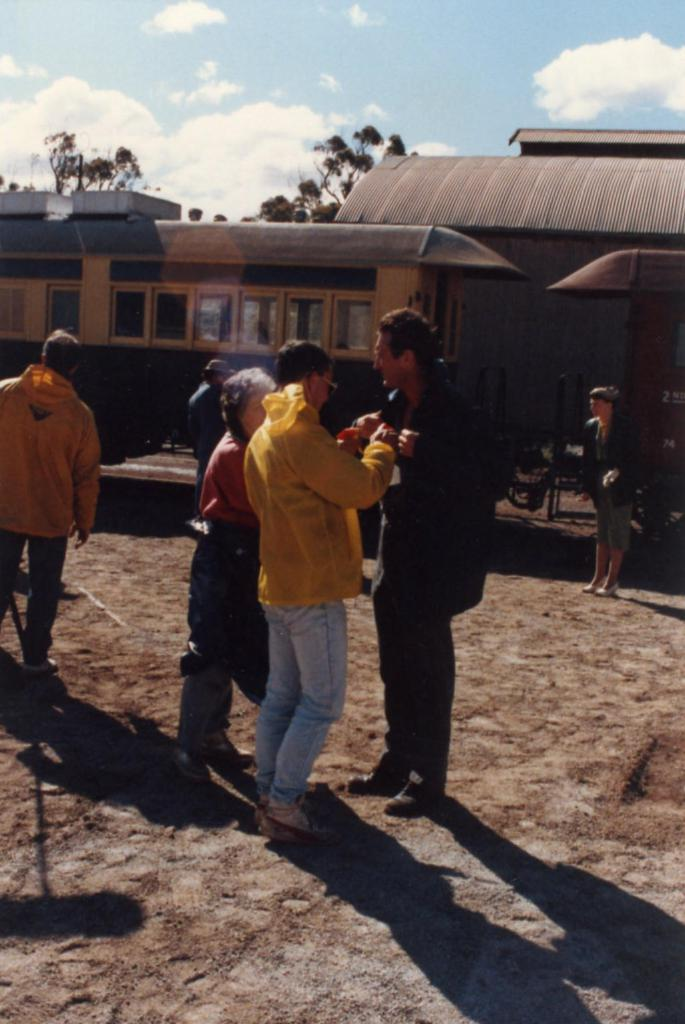What are the people in the image doing? The persons standing on the ground are likely waiting or observing something. What can be seen in the distance behind the people? There is a train, buildings, a roof, and trees in the background. What is visible in the sky? There are clouds in the sky. What type of pet can be seen playing with a jellyfish in the image? There is no pet or jellyfish present in the image; it features persons standing on the ground with various background elements. 